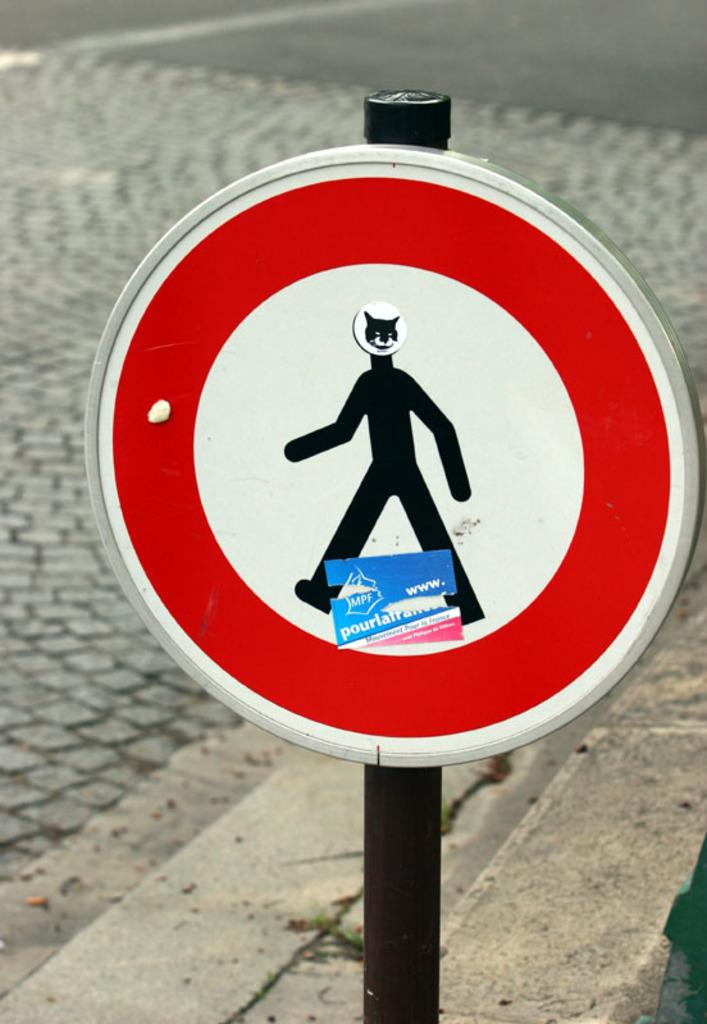What is the main object in the foreground of the image? There is a signal board in the foreground of the image. What can be seen in the background of the image? There is a road visible in the background of the image. What type of protest is taking place in the image? There is no protest present in the image; it only features a signal board and a road in the background. What is the cause of the thunder in the image? There is no thunder present in the image; it only features a signal board and a road in the background. 